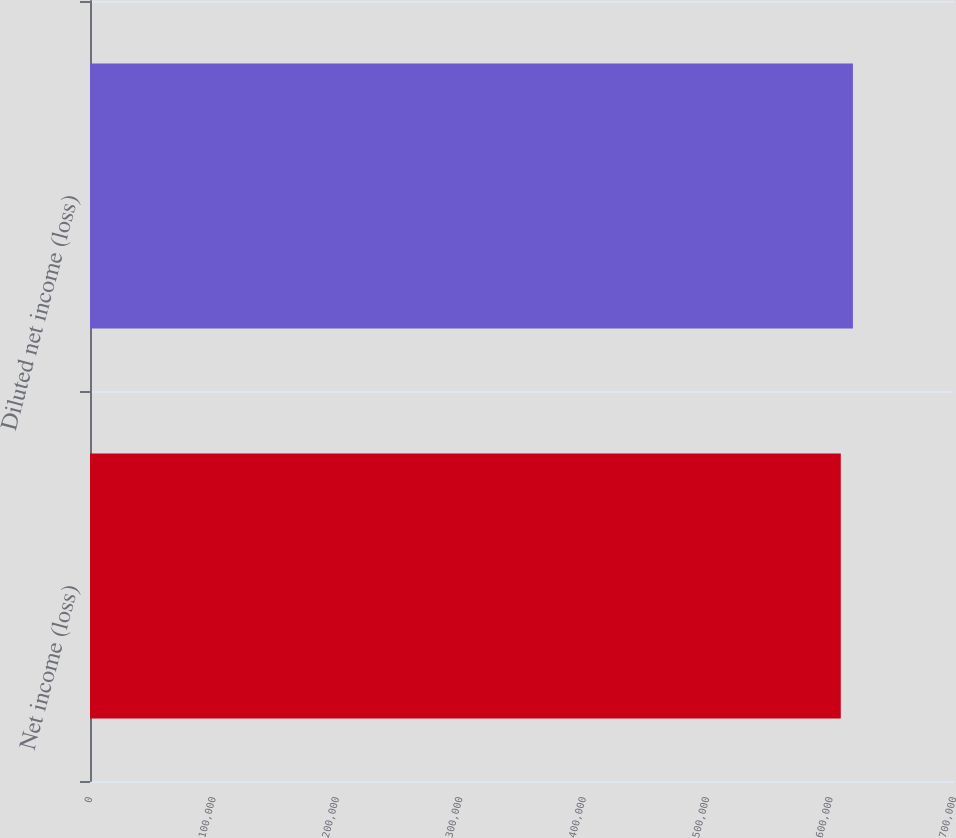Convert chart. <chart><loc_0><loc_0><loc_500><loc_500><bar_chart><fcel>Net income (loss)<fcel>Diluted net income (loss)<nl><fcel>608272<fcel>618106<nl></chart> 